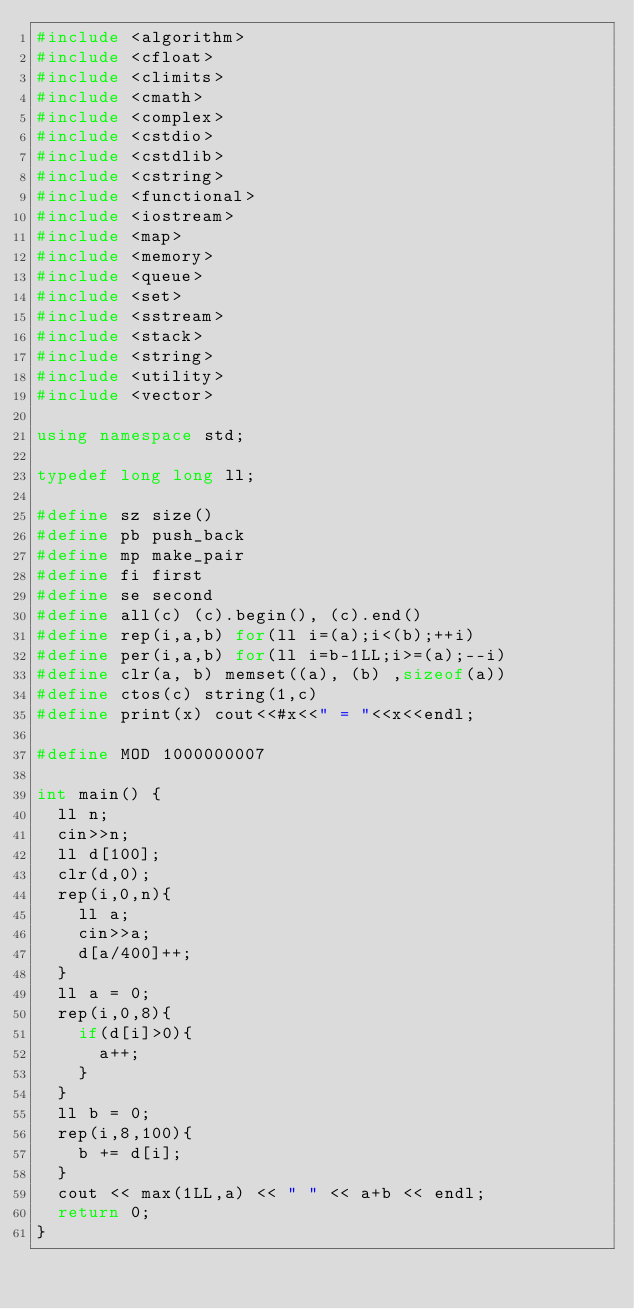Convert code to text. <code><loc_0><loc_0><loc_500><loc_500><_C++_>#include <algorithm>
#include <cfloat>
#include <climits>
#include <cmath>
#include <complex>
#include <cstdio>
#include <cstdlib>
#include <cstring>
#include <functional>
#include <iostream>
#include <map>
#include <memory>
#include <queue>
#include <set>
#include <sstream>
#include <stack>
#include <string>
#include <utility>
#include <vector>
 
using namespace std;
 
typedef long long ll;
 
#define sz size()
#define pb push_back
#define mp make_pair
#define fi first
#define se second
#define all(c) (c).begin(), (c).end()
#define rep(i,a,b) for(ll i=(a);i<(b);++i)
#define per(i,a,b) for(ll i=b-1LL;i>=(a);--i)
#define clr(a, b) memset((a), (b) ,sizeof(a))
#define ctos(c) string(1,c)
#define print(x) cout<<#x<<" = "<<x<<endl;
 
#define MOD 1000000007
 
int main() {
  ll n;
  cin>>n;
  ll d[100];
  clr(d,0);
  rep(i,0,n){
    ll a;
    cin>>a;
    d[a/400]++;
  }
  ll a = 0;
  rep(i,0,8){
    if(d[i]>0){
      a++;
    }
  }
  ll b = 0;
  rep(i,8,100){
    b += d[i];
  }
  cout << max(1LL,a) << " " << a+b << endl;
  return 0;
}</code> 